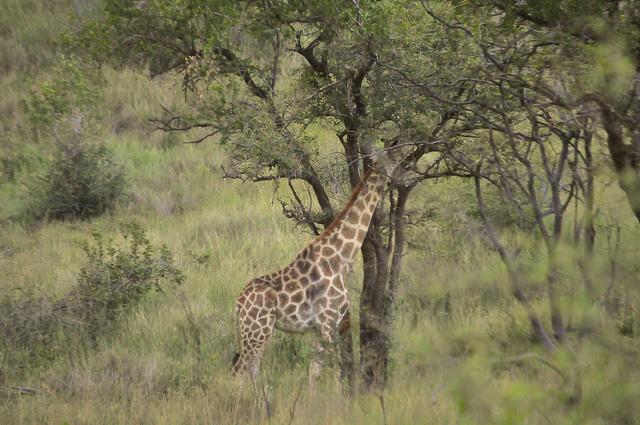How many animals are there?
Short answer required. 1. How many giraffes are in the picture?
Concise answer only. 1. How many giraffes are there?
Give a very brief answer. 1. What is the giraffe eating?
Answer briefly. Leaves. Is the giraffe currently feeding?
Keep it brief. Yes. Is this animal eating?
Be succinct. Yes. 